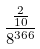<formula> <loc_0><loc_0><loc_500><loc_500>\frac { \frac { 2 } { 1 0 } } { 8 ^ { 3 6 6 } }</formula> 